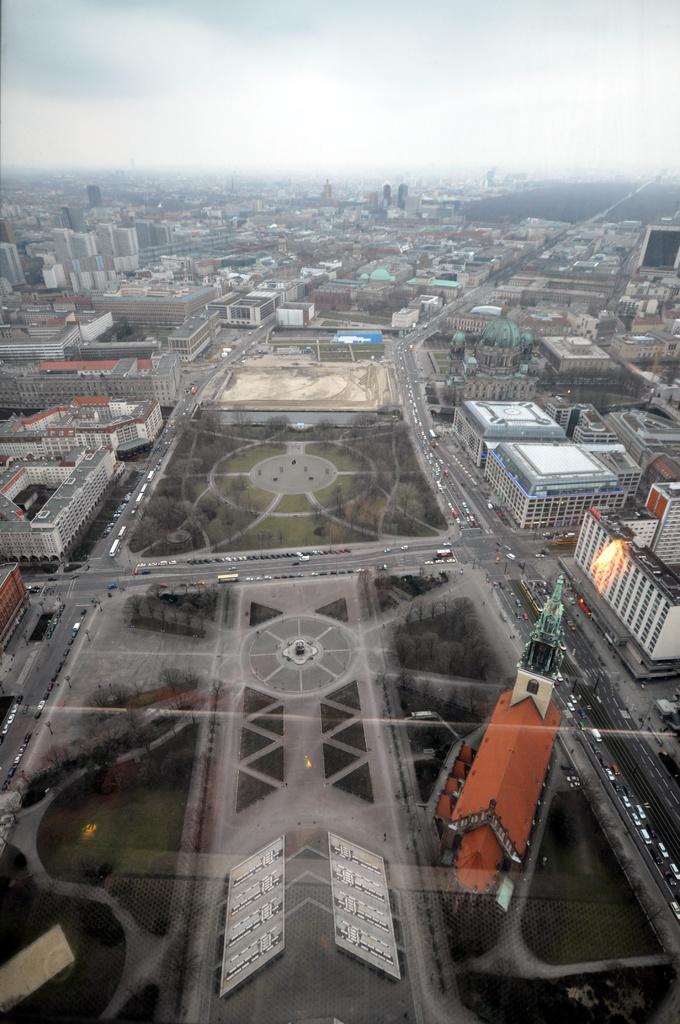In one or two sentences, can you explain what this image depicts? Here in this picture we can see an Ariel view of a city and we can see number of buildings present on the ground and we can also see plants and trees present and we can see the sky is cloudy and we can see vehicles present on the road. 